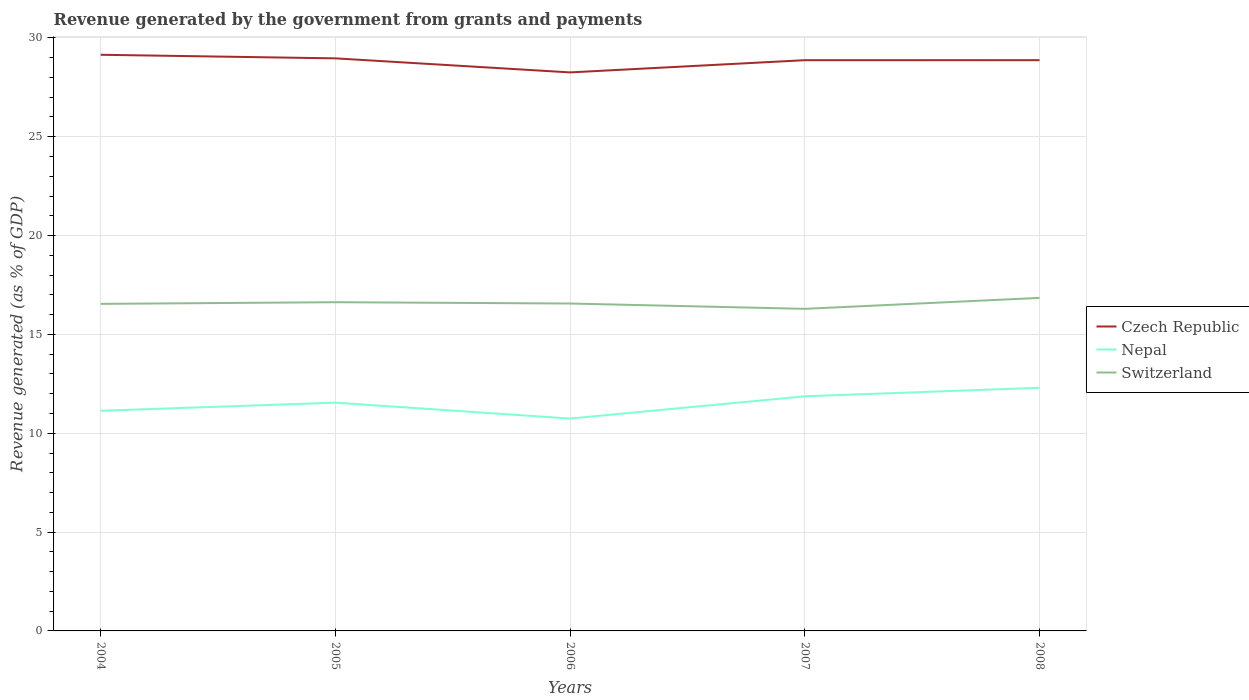Is the number of lines equal to the number of legend labels?
Your answer should be very brief. Yes. Across all years, what is the maximum revenue generated by the government in Nepal?
Your response must be concise. 10.74. In which year was the revenue generated by the government in Czech Republic maximum?
Provide a short and direct response. 2006. What is the total revenue generated by the government in Czech Republic in the graph?
Provide a succinct answer. 0.18. What is the difference between the highest and the second highest revenue generated by the government in Switzerland?
Your answer should be very brief. 0.55. How many lines are there?
Your answer should be very brief. 3. Does the graph contain any zero values?
Offer a very short reply. No. What is the title of the graph?
Make the answer very short. Revenue generated by the government from grants and payments. Does "Botswana" appear as one of the legend labels in the graph?
Your answer should be very brief. No. What is the label or title of the Y-axis?
Your answer should be very brief. Revenue generated (as % of GDP). What is the Revenue generated (as % of GDP) of Czech Republic in 2004?
Make the answer very short. 29.15. What is the Revenue generated (as % of GDP) in Nepal in 2004?
Provide a succinct answer. 11.14. What is the Revenue generated (as % of GDP) of Switzerland in 2004?
Ensure brevity in your answer.  16.55. What is the Revenue generated (as % of GDP) in Czech Republic in 2005?
Keep it short and to the point. 28.97. What is the Revenue generated (as % of GDP) in Nepal in 2005?
Offer a very short reply. 11.55. What is the Revenue generated (as % of GDP) in Switzerland in 2005?
Offer a very short reply. 16.63. What is the Revenue generated (as % of GDP) of Czech Republic in 2006?
Offer a very short reply. 28.25. What is the Revenue generated (as % of GDP) in Nepal in 2006?
Your answer should be compact. 10.74. What is the Revenue generated (as % of GDP) of Switzerland in 2006?
Offer a very short reply. 16.56. What is the Revenue generated (as % of GDP) in Czech Republic in 2007?
Give a very brief answer. 28.87. What is the Revenue generated (as % of GDP) of Nepal in 2007?
Give a very brief answer. 11.87. What is the Revenue generated (as % of GDP) of Switzerland in 2007?
Ensure brevity in your answer.  16.29. What is the Revenue generated (as % of GDP) in Czech Republic in 2008?
Your answer should be compact. 28.87. What is the Revenue generated (as % of GDP) in Nepal in 2008?
Your response must be concise. 12.3. What is the Revenue generated (as % of GDP) of Switzerland in 2008?
Your answer should be compact. 16.85. Across all years, what is the maximum Revenue generated (as % of GDP) in Czech Republic?
Your answer should be compact. 29.15. Across all years, what is the maximum Revenue generated (as % of GDP) of Nepal?
Your answer should be compact. 12.3. Across all years, what is the maximum Revenue generated (as % of GDP) of Switzerland?
Give a very brief answer. 16.85. Across all years, what is the minimum Revenue generated (as % of GDP) in Czech Republic?
Provide a short and direct response. 28.25. Across all years, what is the minimum Revenue generated (as % of GDP) of Nepal?
Provide a succinct answer. 10.74. Across all years, what is the minimum Revenue generated (as % of GDP) of Switzerland?
Offer a very short reply. 16.29. What is the total Revenue generated (as % of GDP) of Czech Republic in the graph?
Make the answer very short. 144.12. What is the total Revenue generated (as % of GDP) of Nepal in the graph?
Ensure brevity in your answer.  57.6. What is the total Revenue generated (as % of GDP) in Switzerland in the graph?
Offer a terse response. 82.88. What is the difference between the Revenue generated (as % of GDP) of Czech Republic in 2004 and that in 2005?
Offer a very short reply. 0.18. What is the difference between the Revenue generated (as % of GDP) of Nepal in 2004 and that in 2005?
Provide a succinct answer. -0.41. What is the difference between the Revenue generated (as % of GDP) in Switzerland in 2004 and that in 2005?
Ensure brevity in your answer.  -0.08. What is the difference between the Revenue generated (as % of GDP) in Czech Republic in 2004 and that in 2006?
Offer a very short reply. 0.89. What is the difference between the Revenue generated (as % of GDP) in Nepal in 2004 and that in 2006?
Provide a succinct answer. 0.39. What is the difference between the Revenue generated (as % of GDP) in Switzerland in 2004 and that in 2006?
Your response must be concise. -0.02. What is the difference between the Revenue generated (as % of GDP) of Czech Republic in 2004 and that in 2007?
Offer a terse response. 0.27. What is the difference between the Revenue generated (as % of GDP) in Nepal in 2004 and that in 2007?
Keep it short and to the point. -0.73. What is the difference between the Revenue generated (as % of GDP) of Switzerland in 2004 and that in 2007?
Provide a succinct answer. 0.25. What is the difference between the Revenue generated (as % of GDP) of Czech Republic in 2004 and that in 2008?
Provide a succinct answer. 0.27. What is the difference between the Revenue generated (as % of GDP) of Nepal in 2004 and that in 2008?
Make the answer very short. -1.16. What is the difference between the Revenue generated (as % of GDP) of Switzerland in 2004 and that in 2008?
Provide a short and direct response. -0.3. What is the difference between the Revenue generated (as % of GDP) of Czech Republic in 2005 and that in 2006?
Ensure brevity in your answer.  0.71. What is the difference between the Revenue generated (as % of GDP) of Nepal in 2005 and that in 2006?
Keep it short and to the point. 0.8. What is the difference between the Revenue generated (as % of GDP) in Switzerland in 2005 and that in 2006?
Provide a short and direct response. 0.07. What is the difference between the Revenue generated (as % of GDP) of Czech Republic in 2005 and that in 2007?
Provide a short and direct response. 0.09. What is the difference between the Revenue generated (as % of GDP) of Nepal in 2005 and that in 2007?
Your answer should be very brief. -0.32. What is the difference between the Revenue generated (as % of GDP) in Switzerland in 2005 and that in 2007?
Make the answer very short. 0.34. What is the difference between the Revenue generated (as % of GDP) of Czech Republic in 2005 and that in 2008?
Provide a short and direct response. 0.09. What is the difference between the Revenue generated (as % of GDP) in Nepal in 2005 and that in 2008?
Your answer should be very brief. -0.75. What is the difference between the Revenue generated (as % of GDP) of Switzerland in 2005 and that in 2008?
Your answer should be very brief. -0.22. What is the difference between the Revenue generated (as % of GDP) of Czech Republic in 2006 and that in 2007?
Your answer should be compact. -0.62. What is the difference between the Revenue generated (as % of GDP) in Nepal in 2006 and that in 2007?
Offer a terse response. -1.13. What is the difference between the Revenue generated (as % of GDP) in Switzerland in 2006 and that in 2007?
Ensure brevity in your answer.  0.27. What is the difference between the Revenue generated (as % of GDP) of Czech Republic in 2006 and that in 2008?
Your answer should be compact. -0.62. What is the difference between the Revenue generated (as % of GDP) in Nepal in 2006 and that in 2008?
Offer a very short reply. -1.56. What is the difference between the Revenue generated (as % of GDP) of Switzerland in 2006 and that in 2008?
Provide a succinct answer. -0.28. What is the difference between the Revenue generated (as % of GDP) in Czech Republic in 2007 and that in 2008?
Make the answer very short. -0. What is the difference between the Revenue generated (as % of GDP) in Nepal in 2007 and that in 2008?
Ensure brevity in your answer.  -0.43. What is the difference between the Revenue generated (as % of GDP) in Switzerland in 2007 and that in 2008?
Offer a very short reply. -0.55. What is the difference between the Revenue generated (as % of GDP) of Czech Republic in 2004 and the Revenue generated (as % of GDP) of Nepal in 2005?
Make the answer very short. 17.6. What is the difference between the Revenue generated (as % of GDP) in Czech Republic in 2004 and the Revenue generated (as % of GDP) in Switzerland in 2005?
Ensure brevity in your answer.  12.52. What is the difference between the Revenue generated (as % of GDP) in Nepal in 2004 and the Revenue generated (as % of GDP) in Switzerland in 2005?
Your answer should be very brief. -5.49. What is the difference between the Revenue generated (as % of GDP) in Czech Republic in 2004 and the Revenue generated (as % of GDP) in Nepal in 2006?
Offer a very short reply. 18.4. What is the difference between the Revenue generated (as % of GDP) in Czech Republic in 2004 and the Revenue generated (as % of GDP) in Switzerland in 2006?
Give a very brief answer. 12.58. What is the difference between the Revenue generated (as % of GDP) in Nepal in 2004 and the Revenue generated (as % of GDP) in Switzerland in 2006?
Provide a succinct answer. -5.43. What is the difference between the Revenue generated (as % of GDP) of Czech Republic in 2004 and the Revenue generated (as % of GDP) of Nepal in 2007?
Your response must be concise. 17.28. What is the difference between the Revenue generated (as % of GDP) in Czech Republic in 2004 and the Revenue generated (as % of GDP) in Switzerland in 2007?
Your answer should be compact. 12.85. What is the difference between the Revenue generated (as % of GDP) of Nepal in 2004 and the Revenue generated (as % of GDP) of Switzerland in 2007?
Offer a very short reply. -5.16. What is the difference between the Revenue generated (as % of GDP) in Czech Republic in 2004 and the Revenue generated (as % of GDP) in Nepal in 2008?
Offer a terse response. 16.85. What is the difference between the Revenue generated (as % of GDP) in Czech Republic in 2004 and the Revenue generated (as % of GDP) in Switzerland in 2008?
Give a very brief answer. 12.3. What is the difference between the Revenue generated (as % of GDP) of Nepal in 2004 and the Revenue generated (as % of GDP) of Switzerland in 2008?
Make the answer very short. -5.71. What is the difference between the Revenue generated (as % of GDP) of Czech Republic in 2005 and the Revenue generated (as % of GDP) of Nepal in 2006?
Your answer should be very brief. 18.22. What is the difference between the Revenue generated (as % of GDP) of Czech Republic in 2005 and the Revenue generated (as % of GDP) of Switzerland in 2006?
Your answer should be compact. 12.4. What is the difference between the Revenue generated (as % of GDP) of Nepal in 2005 and the Revenue generated (as % of GDP) of Switzerland in 2006?
Ensure brevity in your answer.  -5.02. What is the difference between the Revenue generated (as % of GDP) in Czech Republic in 2005 and the Revenue generated (as % of GDP) in Nepal in 2007?
Keep it short and to the point. 17.1. What is the difference between the Revenue generated (as % of GDP) in Czech Republic in 2005 and the Revenue generated (as % of GDP) in Switzerland in 2007?
Your response must be concise. 12.67. What is the difference between the Revenue generated (as % of GDP) of Nepal in 2005 and the Revenue generated (as % of GDP) of Switzerland in 2007?
Make the answer very short. -4.75. What is the difference between the Revenue generated (as % of GDP) in Czech Republic in 2005 and the Revenue generated (as % of GDP) in Nepal in 2008?
Your response must be concise. 16.67. What is the difference between the Revenue generated (as % of GDP) of Czech Republic in 2005 and the Revenue generated (as % of GDP) of Switzerland in 2008?
Your answer should be compact. 12.12. What is the difference between the Revenue generated (as % of GDP) in Nepal in 2005 and the Revenue generated (as % of GDP) in Switzerland in 2008?
Offer a terse response. -5.3. What is the difference between the Revenue generated (as % of GDP) in Czech Republic in 2006 and the Revenue generated (as % of GDP) in Nepal in 2007?
Your response must be concise. 16.39. What is the difference between the Revenue generated (as % of GDP) of Czech Republic in 2006 and the Revenue generated (as % of GDP) of Switzerland in 2007?
Give a very brief answer. 11.96. What is the difference between the Revenue generated (as % of GDP) of Nepal in 2006 and the Revenue generated (as % of GDP) of Switzerland in 2007?
Your answer should be very brief. -5.55. What is the difference between the Revenue generated (as % of GDP) in Czech Republic in 2006 and the Revenue generated (as % of GDP) in Nepal in 2008?
Give a very brief answer. 15.95. What is the difference between the Revenue generated (as % of GDP) of Czech Republic in 2006 and the Revenue generated (as % of GDP) of Switzerland in 2008?
Offer a very short reply. 11.41. What is the difference between the Revenue generated (as % of GDP) of Nepal in 2006 and the Revenue generated (as % of GDP) of Switzerland in 2008?
Your answer should be compact. -6.1. What is the difference between the Revenue generated (as % of GDP) in Czech Republic in 2007 and the Revenue generated (as % of GDP) in Nepal in 2008?
Provide a succinct answer. 16.57. What is the difference between the Revenue generated (as % of GDP) of Czech Republic in 2007 and the Revenue generated (as % of GDP) of Switzerland in 2008?
Provide a succinct answer. 12.03. What is the difference between the Revenue generated (as % of GDP) in Nepal in 2007 and the Revenue generated (as % of GDP) in Switzerland in 2008?
Your answer should be very brief. -4.98. What is the average Revenue generated (as % of GDP) in Czech Republic per year?
Offer a very short reply. 28.82. What is the average Revenue generated (as % of GDP) in Nepal per year?
Give a very brief answer. 11.52. What is the average Revenue generated (as % of GDP) in Switzerland per year?
Your response must be concise. 16.58. In the year 2004, what is the difference between the Revenue generated (as % of GDP) in Czech Republic and Revenue generated (as % of GDP) in Nepal?
Your answer should be very brief. 18.01. In the year 2004, what is the difference between the Revenue generated (as % of GDP) of Czech Republic and Revenue generated (as % of GDP) of Switzerland?
Your answer should be very brief. 12.6. In the year 2004, what is the difference between the Revenue generated (as % of GDP) of Nepal and Revenue generated (as % of GDP) of Switzerland?
Make the answer very short. -5.41. In the year 2005, what is the difference between the Revenue generated (as % of GDP) in Czech Republic and Revenue generated (as % of GDP) in Nepal?
Offer a very short reply. 17.42. In the year 2005, what is the difference between the Revenue generated (as % of GDP) of Czech Republic and Revenue generated (as % of GDP) of Switzerland?
Your answer should be very brief. 12.34. In the year 2005, what is the difference between the Revenue generated (as % of GDP) in Nepal and Revenue generated (as % of GDP) in Switzerland?
Provide a short and direct response. -5.08. In the year 2006, what is the difference between the Revenue generated (as % of GDP) in Czech Republic and Revenue generated (as % of GDP) in Nepal?
Ensure brevity in your answer.  17.51. In the year 2006, what is the difference between the Revenue generated (as % of GDP) in Czech Republic and Revenue generated (as % of GDP) in Switzerland?
Your answer should be very brief. 11.69. In the year 2006, what is the difference between the Revenue generated (as % of GDP) of Nepal and Revenue generated (as % of GDP) of Switzerland?
Offer a very short reply. -5.82. In the year 2007, what is the difference between the Revenue generated (as % of GDP) in Czech Republic and Revenue generated (as % of GDP) in Nepal?
Ensure brevity in your answer.  17. In the year 2007, what is the difference between the Revenue generated (as % of GDP) in Czech Republic and Revenue generated (as % of GDP) in Switzerland?
Your answer should be very brief. 12.58. In the year 2007, what is the difference between the Revenue generated (as % of GDP) in Nepal and Revenue generated (as % of GDP) in Switzerland?
Your response must be concise. -4.42. In the year 2008, what is the difference between the Revenue generated (as % of GDP) of Czech Republic and Revenue generated (as % of GDP) of Nepal?
Offer a terse response. 16.57. In the year 2008, what is the difference between the Revenue generated (as % of GDP) of Czech Republic and Revenue generated (as % of GDP) of Switzerland?
Keep it short and to the point. 12.03. In the year 2008, what is the difference between the Revenue generated (as % of GDP) of Nepal and Revenue generated (as % of GDP) of Switzerland?
Ensure brevity in your answer.  -4.55. What is the ratio of the Revenue generated (as % of GDP) in Nepal in 2004 to that in 2005?
Your answer should be very brief. 0.96. What is the ratio of the Revenue generated (as % of GDP) in Switzerland in 2004 to that in 2005?
Give a very brief answer. 0.99. What is the ratio of the Revenue generated (as % of GDP) of Czech Republic in 2004 to that in 2006?
Offer a very short reply. 1.03. What is the ratio of the Revenue generated (as % of GDP) in Nepal in 2004 to that in 2006?
Offer a terse response. 1.04. What is the ratio of the Revenue generated (as % of GDP) in Czech Republic in 2004 to that in 2007?
Provide a succinct answer. 1.01. What is the ratio of the Revenue generated (as % of GDP) of Nepal in 2004 to that in 2007?
Offer a terse response. 0.94. What is the ratio of the Revenue generated (as % of GDP) in Switzerland in 2004 to that in 2007?
Give a very brief answer. 1.02. What is the ratio of the Revenue generated (as % of GDP) in Czech Republic in 2004 to that in 2008?
Offer a very short reply. 1.01. What is the ratio of the Revenue generated (as % of GDP) in Nepal in 2004 to that in 2008?
Offer a terse response. 0.91. What is the ratio of the Revenue generated (as % of GDP) in Czech Republic in 2005 to that in 2006?
Provide a succinct answer. 1.03. What is the ratio of the Revenue generated (as % of GDP) of Nepal in 2005 to that in 2006?
Make the answer very short. 1.07. What is the ratio of the Revenue generated (as % of GDP) of Switzerland in 2005 to that in 2006?
Your response must be concise. 1. What is the ratio of the Revenue generated (as % of GDP) in Czech Republic in 2005 to that in 2007?
Your response must be concise. 1. What is the ratio of the Revenue generated (as % of GDP) of Nepal in 2005 to that in 2007?
Provide a succinct answer. 0.97. What is the ratio of the Revenue generated (as % of GDP) in Switzerland in 2005 to that in 2007?
Your answer should be very brief. 1.02. What is the ratio of the Revenue generated (as % of GDP) of Nepal in 2005 to that in 2008?
Give a very brief answer. 0.94. What is the ratio of the Revenue generated (as % of GDP) in Switzerland in 2005 to that in 2008?
Provide a short and direct response. 0.99. What is the ratio of the Revenue generated (as % of GDP) in Czech Republic in 2006 to that in 2007?
Provide a short and direct response. 0.98. What is the ratio of the Revenue generated (as % of GDP) in Nepal in 2006 to that in 2007?
Your answer should be compact. 0.91. What is the ratio of the Revenue generated (as % of GDP) in Switzerland in 2006 to that in 2007?
Keep it short and to the point. 1.02. What is the ratio of the Revenue generated (as % of GDP) in Czech Republic in 2006 to that in 2008?
Provide a short and direct response. 0.98. What is the ratio of the Revenue generated (as % of GDP) of Nepal in 2006 to that in 2008?
Give a very brief answer. 0.87. What is the ratio of the Revenue generated (as % of GDP) of Switzerland in 2006 to that in 2008?
Your response must be concise. 0.98. What is the ratio of the Revenue generated (as % of GDP) in Czech Republic in 2007 to that in 2008?
Give a very brief answer. 1. What is the ratio of the Revenue generated (as % of GDP) of Nepal in 2007 to that in 2008?
Offer a very short reply. 0.96. What is the ratio of the Revenue generated (as % of GDP) in Switzerland in 2007 to that in 2008?
Offer a terse response. 0.97. What is the difference between the highest and the second highest Revenue generated (as % of GDP) of Czech Republic?
Give a very brief answer. 0.18. What is the difference between the highest and the second highest Revenue generated (as % of GDP) in Nepal?
Give a very brief answer. 0.43. What is the difference between the highest and the second highest Revenue generated (as % of GDP) of Switzerland?
Ensure brevity in your answer.  0.22. What is the difference between the highest and the lowest Revenue generated (as % of GDP) of Czech Republic?
Offer a terse response. 0.89. What is the difference between the highest and the lowest Revenue generated (as % of GDP) in Nepal?
Ensure brevity in your answer.  1.56. What is the difference between the highest and the lowest Revenue generated (as % of GDP) in Switzerland?
Offer a terse response. 0.55. 